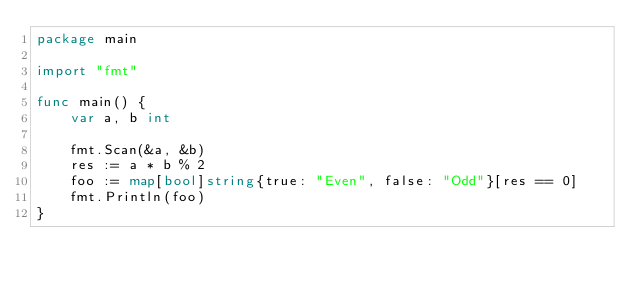Convert code to text. <code><loc_0><loc_0><loc_500><loc_500><_Go_>package main

import "fmt"

func main() {
	var a, b int

	fmt.Scan(&a, &b)
	res := a * b % 2
	foo := map[bool]string{true: "Even", false: "Odd"}[res == 0]
	fmt.Println(foo)
}
</code> 